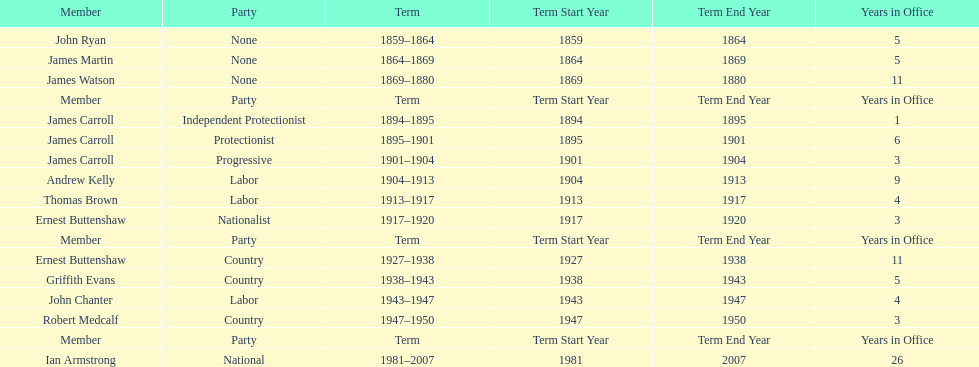How long did the fourth incarnation of the lachlan exist? 1981-2007. 